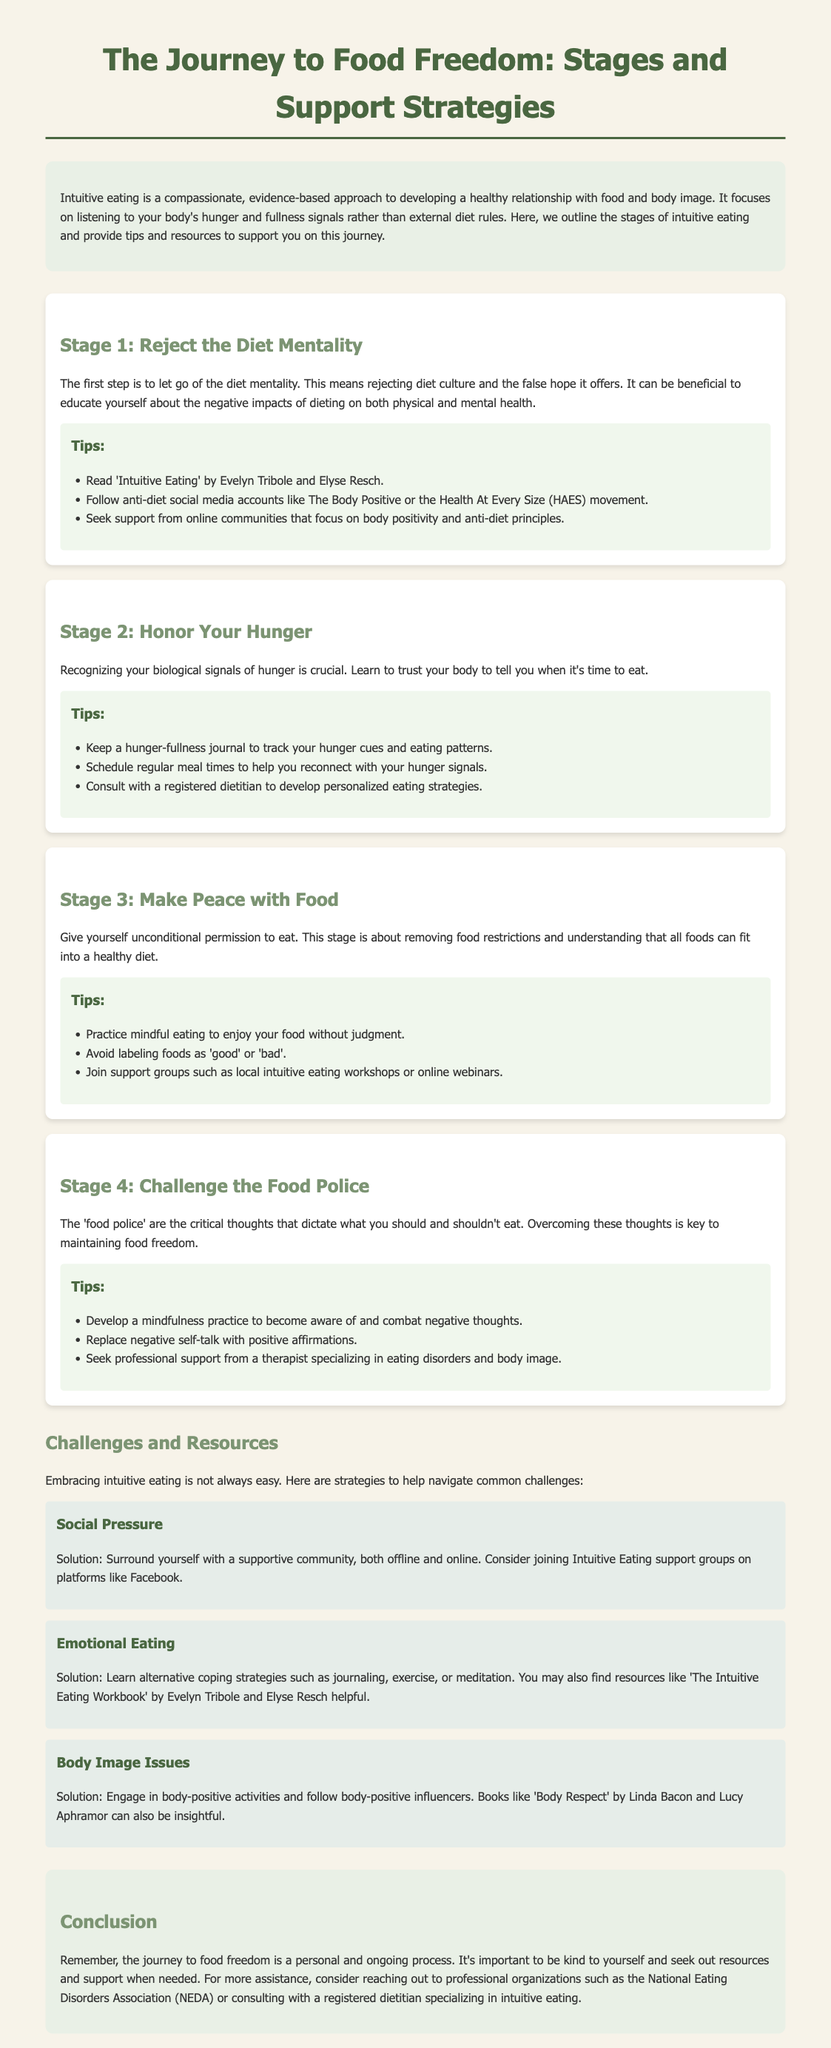What is the first stage of intuitive eating? The first stage outlined in the document is about rejecting the diet mentality.
Answer: Reject the Diet Mentality Which book is recommended in Stage 1? The document mentions recommending a specific book that addresses intuitive eating principles in Stage 1.
Answer: 'Intuitive Eating' by Evelyn Tribole and Elyse Resch What is one tip for Stage 2? The document provides various practical suggestions for recognizing hunger signals in Stage 2, one of which is specified here.
Answer: Keep a hunger-fullness journal What is a common challenge mentioned in the document? The document identifies different challenges associated with intuitive eating, highlighting a few specific issues one may encounter.
Answer: Emotional Eating Which resource is suggested for body image issues? The document provides a recommendation for resources specifically addressing body image concerns.
Answer: 'Body Respect' by Linda Bacon and Lucy Aphramor What is the color of the document's background? This inquiry pertains to the overall visual design of the fact sheet, specifically regarding its background color.
Answer: #f7f3e9 What is the role of a registered dietitian according to the document? The document indicates a specific function or responsibility of a registered dietitian in relation to intuitive eating.
Answer: Develop personalized eating strategies What type of community support is suggested for social pressure? The document outlines specific ways to combat social peer pressures related to eating.
Answer: Intuitive Eating support groups What is one positive affirmation action suggested in Stage 4? The document provides strategies for overcoming negative self-talk in Stage 4, specifying actions that can be taken.
Answer: Replace negative self-talk with positive affirmations 